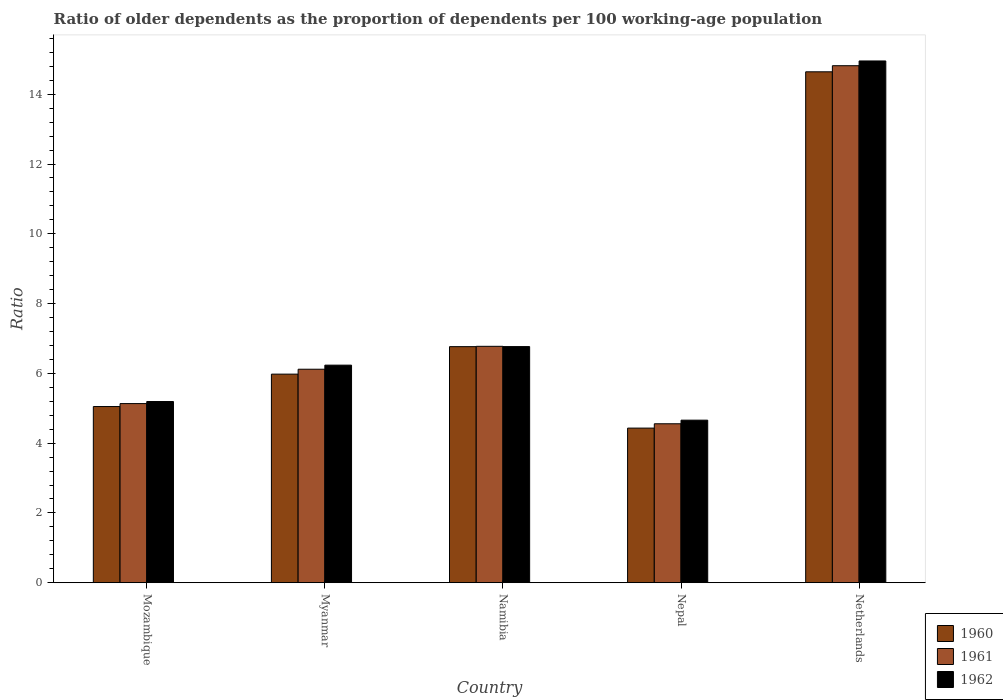How many different coloured bars are there?
Keep it short and to the point. 3. How many groups of bars are there?
Keep it short and to the point. 5. Are the number of bars on each tick of the X-axis equal?
Your response must be concise. Yes. How many bars are there on the 3rd tick from the left?
Provide a succinct answer. 3. How many bars are there on the 2nd tick from the right?
Your response must be concise. 3. What is the label of the 3rd group of bars from the left?
Offer a very short reply. Namibia. In how many cases, is the number of bars for a given country not equal to the number of legend labels?
Provide a short and direct response. 0. What is the age dependency ratio(old) in 1962 in Nepal?
Keep it short and to the point. 4.66. Across all countries, what is the maximum age dependency ratio(old) in 1961?
Your answer should be compact. 14.82. Across all countries, what is the minimum age dependency ratio(old) in 1961?
Your answer should be very brief. 4.56. In which country was the age dependency ratio(old) in 1960 maximum?
Offer a very short reply. Netherlands. In which country was the age dependency ratio(old) in 1960 minimum?
Offer a very short reply. Nepal. What is the total age dependency ratio(old) in 1962 in the graph?
Provide a succinct answer. 37.81. What is the difference between the age dependency ratio(old) in 1960 in Nepal and that in Netherlands?
Your answer should be very brief. -10.21. What is the difference between the age dependency ratio(old) in 1962 in Namibia and the age dependency ratio(old) in 1960 in Nepal?
Your answer should be very brief. 2.34. What is the average age dependency ratio(old) in 1962 per country?
Give a very brief answer. 7.56. What is the difference between the age dependency ratio(old) of/in 1960 and age dependency ratio(old) of/in 1962 in Nepal?
Give a very brief answer. -0.23. What is the ratio of the age dependency ratio(old) in 1962 in Mozambique to that in Nepal?
Your answer should be very brief. 1.11. Is the age dependency ratio(old) in 1960 in Namibia less than that in Nepal?
Ensure brevity in your answer.  No. What is the difference between the highest and the second highest age dependency ratio(old) in 1962?
Ensure brevity in your answer.  -8.72. What is the difference between the highest and the lowest age dependency ratio(old) in 1960?
Offer a very short reply. 10.21. In how many countries, is the age dependency ratio(old) in 1962 greater than the average age dependency ratio(old) in 1962 taken over all countries?
Your response must be concise. 1. Is the sum of the age dependency ratio(old) in 1960 in Mozambique and Myanmar greater than the maximum age dependency ratio(old) in 1961 across all countries?
Provide a short and direct response. No. What does the 3rd bar from the left in Netherlands represents?
Your answer should be compact. 1962. What does the 1st bar from the right in Namibia represents?
Give a very brief answer. 1962. How many countries are there in the graph?
Your answer should be very brief. 5. What is the difference between two consecutive major ticks on the Y-axis?
Your answer should be compact. 2. Are the values on the major ticks of Y-axis written in scientific E-notation?
Ensure brevity in your answer.  No. Does the graph contain any zero values?
Offer a terse response. No. Where does the legend appear in the graph?
Make the answer very short. Bottom right. What is the title of the graph?
Make the answer very short. Ratio of older dependents as the proportion of dependents per 100 working-age population. What is the label or title of the X-axis?
Your answer should be very brief. Country. What is the label or title of the Y-axis?
Provide a short and direct response. Ratio. What is the Ratio of 1960 in Mozambique?
Keep it short and to the point. 5.05. What is the Ratio of 1961 in Mozambique?
Offer a very short reply. 5.13. What is the Ratio in 1962 in Mozambique?
Your answer should be compact. 5.19. What is the Ratio in 1960 in Myanmar?
Your answer should be compact. 5.98. What is the Ratio in 1961 in Myanmar?
Offer a terse response. 6.12. What is the Ratio of 1962 in Myanmar?
Provide a short and direct response. 6.24. What is the Ratio in 1960 in Namibia?
Your answer should be compact. 6.77. What is the Ratio in 1961 in Namibia?
Give a very brief answer. 6.77. What is the Ratio of 1962 in Namibia?
Give a very brief answer. 6.77. What is the Ratio in 1960 in Nepal?
Make the answer very short. 4.43. What is the Ratio in 1961 in Nepal?
Provide a succinct answer. 4.56. What is the Ratio of 1962 in Nepal?
Offer a terse response. 4.66. What is the Ratio in 1960 in Netherlands?
Provide a short and direct response. 14.64. What is the Ratio of 1961 in Netherlands?
Provide a succinct answer. 14.82. What is the Ratio in 1962 in Netherlands?
Ensure brevity in your answer.  14.95. Across all countries, what is the maximum Ratio in 1960?
Your answer should be very brief. 14.64. Across all countries, what is the maximum Ratio in 1961?
Offer a very short reply. 14.82. Across all countries, what is the maximum Ratio in 1962?
Your response must be concise. 14.95. Across all countries, what is the minimum Ratio in 1960?
Offer a terse response. 4.43. Across all countries, what is the minimum Ratio in 1961?
Your answer should be very brief. 4.56. Across all countries, what is the minimum Ratio in 1962?
Provide a short and direct response. 4.66. What is the total Ratio in 1960 in the graph?
Keep it short and to the point. 36.87. What is the total Ratio in 1961 in the graph?
Ensure brevity in your answer.  37.4. What is the total Ratio of 1962 in the graph?
Make the answer very short. 37.81. What is the difference between the Ratio of 1960 in Mozambique and that in Myanmar?
Make the answer very short. -0.93. What is the difference between the Ratio of 1961 in Mozambique and that in Myanmar?
Your answer should be very brief. -0.98. What is the difference between the Ratio of 1962 in Mozambique and that in Myanmar?
Provide a short and direct response. -1.04. What is the difference between the Ratio of 1960 in Mozambique and that in Namibia?
Offer a very short reply. -1.72. What is the difference between the Ratio of 1961 in Mozambique and that in Namibia?
Make the answer very short. -1.64. What is the difference between the Ratio in 1962 in Mozambique and that in Namibia?
Provide a succinct answer. -1.57. What is the difference between the Ratio in 1960 in Mozambique and that in Nepal?
Your answer should be very brief. 0.62. What is the difference between the Ratio in 1961 in Mozambique and that in Nepal?
Offer a terse response. 0.58. What is the difference between the Ratio in 1962 in Mozambique and that in Nepal?
Keep it short and to the point. 0.53. What is the difference between the Ratio in 1960 in Mozambique and that in Netherlands?
Make the answer very short. -9.59. What is the difference between the Ratio in 1961 in Mozambique and that in Netherlands?
Your response must be concise. -9.68. What is the difference between the Ratio of 1962 in Mozambique and that in Netherlands?
Provide a short and direct response. -9.76. What is the difference between the Ratio of 1960 in Myanmar and that in Namibia?
Your answer should be compact. -0.79. What is the difference between the Ratio in 1961 in Myanmar and that in Namibia?
Ensure brevity in your answer.  -0.66. What is the difference between the Ratio in 1962 in Myanmar and that in Namibia?
Provide a succinct answer. -0.53. What is the difference between the Ratio in 1960 in Myanmar and that in Nepal?
Offer a very short reply. 1.55. What is the difference between the Ratio in 1961 in Myanmar and that in Nepal?
Offer a terse response. 1.56. What is the difference between the Ratio in 1962 in Myanmar and that in Nepal?
Provide a succinct answer. 1.58. What is the difference between the Ratio of 1960 in Myanmar and that in Netherlands?
Provide a short and direct response. -8.66. What is the difference between the Ratio in 1961 in Myanmar and that in Netherlands?
Give a very brief answer. -8.7. What is the difference between the Ratio of 1962 in Myanmar and that in Netherlands?
Offer a very short reply. -8.72. What is the difference between the Ratio in 1960 in Namibia and that in Nepal?
Give a very brief answer. 2.33. What is the difference between the Ratio of 1961 in Namibia and that in Nepal?
Your answer should be compact. 2.22. What is the difference between the Ratio in 1962 in Namibia and that in Nepal?
Your answer should be very brief. 2.11. What is the difference between the Ratio of 1960 in Namibia and that in Netherlands?
Provide a succinct answer. -7.88. What is the difference between the Ratio in 1961 in Namibia and that in Netherlands?
Make the answer very short. -8.04. What is the difference between the Ratio in 1962 in Namibia and that in Netherlands?
Provide a succinct answer. -8.19. What is the difference between the Ratio in 1960 in Nepal and that in Netherlands?
Ensure brevity in your answer.  -10.21. What is the difference between the Ratio in 1961 in Nepal and that in Netherlands?
Make the answer very short. -10.26. What is the difference between the Ratio of 1962 in Nepal and that in Netherlands?
Offer a very short reply. -10.29. What is the difference between the Ratio of 1960 in Mozambique and the Ratio of 1961 in Myanmar?
Your answer should be very brief. -1.07. What is the difference between the Ratio of 1960 in Mozambique and the Ratio of 1962 in Myanmar?
Your response must be concise. -1.19. What is the difference between the Ratio in 1961 in Mozambique and the Ratio in 1962 in Myanmar?
Provide a short and direct response. -1.1. What is the difference between the Ratio in 1960 in Mozambique and the Ratio in 1961 in Namibia?
Your answer should be compact. -1.73. What is the difference between the Ratio in 1960 in Mozambique and the Ratio in 1962 in Namibia?
Your answer should be compact. -1.72. What is the difference between the Ratio of 1961 in Mozambique and the Ratio of 1962 in Namibia?
Your answer should be very brief. -1.63. What is the difference between the Ratio in 1960 in Mozambique and the Ratio in 1961 in Nepal?
Give a very brief answer. 0.49. What is the difference between the Ratio of 1960 in Mozambique and the Ratio of 1962 in Nepal?
Ensure brevity in your answer.  0.39. What is the difference between the Ratio of 1961 in Mozambique and the Ratio of 1962 in Nepal?
Keep it short and to the point. 0.48. What is the difference between the Ratio of 1960 in Mozambique and the Ratio of 1961 in Netherlands?
Your answer should be very brief. -9.77. What is the difference between the Ratio in 1960 in Mozambique and the Ratio in 1962 in Netherlands?
Ensure brevity in your answer.  -9.9. What is the difference between the Ratio of 1961 in Mozambique and the Ratio of 1962 in Netherlands?
Your response must be concise. -9.82. What is the difference between the Ratio of 1960 in Myanmar and the Ratio of 1961 in Namibia?
Provide a short and direct response. -0.8. What is the difference between the Ratio of 1960 in Myanmar and the Ratio of 1962 in Namibia?
Your answer should be compact. -0.79. What is the difference between the Ratio in 1961 in Myanmar and the Ratio in 1962 in Namibia?
Keep it short and to the point. -0.65. What is the difference between the Ratio in 1960 in Myanmar and the Ratio in 1961 in Nepal?
Give a very brief answer. 1.42. What is the difference between the Ratio in 1960 in Myanmar and the Ratio in 1962 in Nepal?
Your response must be concise. 1.32. What is the difference between the Ratio in 1961 in Myanmar and the Ratio in 1962 in Nepal?
Provide a short and direct response. 1.46. What is the difference between the Ratio of 1960 in Myanmar and the Ratio of 1961 in Netherlands?
Your answer should be very brief. -8.84. What is the difference between the Ratio of 1960 in Myanmar and the Ratio of 1962 in Netherlands?
Your answer should be very brief. -8.98. What is the difference between the Ratio of 1961 in Myanmar and the Ratio of 1962 in Netherlands?
Ensure brevity in your answer.  -8.83. What is the difference between the Ratio in 1960 in Namibia and the Ratio in 1961 in Nepal?
Provide a short and direct response. 2.21. What is the difference between the Ratio in 1960 in Namibia and the Ratio in 1962 in Nepal?
Your answer should be compact. 2.11. What is the difference between the Ratio in 1961 in Namibia and the Ratio in 1962 in Nepal?
Offer a very short reply. 2.12. What is the difference between the Ratio of 1960 in Namibia and the Ratio of 1961 in Netherlands?
Ensure brevity in your answer.  -8.05. What is the difference between the Ratio in 1960 in Namibia and the Ratio in 1962 in Netherlands?
Make the answer very short. -8.19. What is the difference between the Ratio in 1961 in Namibia and the Ratio in 1962 in Netherlands?
Make the answer very short. -8.18. What is the difference between the Ratio in 1960 in Nepal and the Ratio in 1961 in Netherlands?
Your response must be concise. -10.39. What is the difference between the Ratio in 1960 in Nepal and the Ratio in 1962 in Netherlands?
Offer a terse response. -10.52. What is the difference between the Ratio of 1961 in Nepal and the Ratio of 1962 in Netherlands?
Offer a terse response. -10.4. What is the average Ratio in 1960 per country?
Give a very brief answer. 7.37. What is the average Ratio in 1961 per country?
Make the answer very short. 7.48. What is the average Ratio of 1962 per country?
Offer a terse response. 7.56. What is the difference between the Ratio of 1960 and Ratio of 1961 in Mozambique?
Give a very brief answer. -0.08. What is the difference between the Ratio of 1960 and Ratio of 1962 in Mozambique?
Your answer should be compact. -0.14. What is the difference between the Ratio in 1961 and Ratio in 1962 in Mozambique?
Give a very brief answer. -0.06. What is the difference between the Ratio of 1960 and Ratio of 1961 in Myanmar?
Ensure brevity in your answer.  -0.14. What is the difference between the Ratio of 1960 and Ratio of 1962 in Myanmar?
Your response must be concise. -0.26. What is the difference between the Ratio of 1961 and Ratio of 1962 in Myanmar?
Provide a succinct answer. -0.12. What is the difference between the Ratio of 1960 and Ratio of 1961 in Namibia?
Make the answer very short. -0.01. What is the difference between the Ratio in 1960 and Ratio in 1962 in Namibia?
Your answer should be compact. -0. What is the difference between the Ratio of 1961 and Ratio of 1962 in Namibia?
Keep it short and to the point. 0.01. What is the difference between the Ratio in 1960 and Ratio in 1961 in Nepal?
Your response must be concise. -0.12. What is the difference between the Ratio in 1960 and Ratio in 1962 in Nepal?
Give a very brief answer. -0.23. What is the difference between the Ratio of 1961 and Ratio of 1962 in Nepal?
Provide a short and direct response. -0.1. What is the difference between the Ratio in 1960 and Ratio in 1961 in Netherlands?
Keep it short and to the point. -0.17. What is the difference between the Ratio of 1960 and Ratio of 1962 in Netherlands?
Your response must be concise. -0.31. What is the difference between the Ratio in 1961 and Ratio in 1962 in Netherlands?
Provide a succinct answer. -0.14. What is the ratio of the Ratio of 1960 in Mozambique to that in Myanmar?
Your answer should be compact. 0.84. What is the ratio of the Ratio in 1961 in Mozambique to that in Myanmar?
Ensure brevity in your answer.  0.84. What is the ratio of the Ratio of 1962 in Mozambique to that in Myanmar?
Make the answer very short. 0.83. What is the ratio of the Ratio of 1960 in Mozambique to that in Namibia?
Your answer should be compact. 0.75. What is the ratio of the Ratio in 1961 in Mozambique to that in Namibia?
Offer a terse response. 0.76. What is the ratio of the Ratio in 1962 in Mozambique to that in Namibia?
Provide a short and direct response. 0.77. What is the ratio of the Ratio of 1960 in Mozambique to that in Nepal?
Offer a terse response. 1.14. What is the ratio of the Ratio in 1961 in Mozambique to that in Nepal?
Your answer should be compact. 1.13. What is the ratio of the Ratio in 1962 in Mozambique to that in Nepal?
Ensure brevity in your answer.  1.11. What is the ratio of the Ratio of 1960 in Mozambique to that in Netherlands?
Provide a succinct answer. 0.34. What is the ratio of the Ratio of 1961 in Mozambique to that in Netherlands?
Give a very brief answer. 0.35. What is the ratio of the Ratio of 1962 in Mozambique to that in Netherlands?
Your response must be concise. 0.35. What is the ratio of the Ratio in 1960 in Myanmar to that in Namibia?
Keep it short and to the point. 0.88. What is the ratio of the Ratio in 1961 in Myanmar to that in Namibia?
Provide a succinct answer. 0.9. What is the ratio of the Ratio of 1962 in Myanmar to that in Namibia?
Keep it short and to the point. 0.92. What is the ratio of the Ratio in 1960 in Myanmar to that in Nepal?
Give a very brief answer. 1.35. What is the ratio of the Ratio of 1961 in Myanmar to that in Nepal?
Offer a terse response. 1.34. What is the ratio of the Ratio in 1962 in Myanmar to that in Nepal?
Offer a terse response. 1.34. What is the ratio of the Ratio in 1960 in Myanmar to that in Netherlands?
Ensure brevity in your answer.  0.41. What is the ratio of the Ratio of 1961 in Myanmar to that in Netherlands?
Your response must be concise. 0.41. What is the ratio of the Ratio in 1962 in Myanmar to that in Netherlands?
Offer a terse response. 0.42. What is the ratio of the Ratio of 1960 in Namibia to that in Nepal?
Provide a short and direct response. 1.53. What is the ratio of the Ratio in 1961 in Namibia to that in Nepal?
Your answer should be very brief. 1.49. What is the ratio of the Ratio of 1962 in Namibia to that in Nepal?
Your response must be concise. 1.45. What is the ratio of the Ratio in 1960 in Namibia to that in Netherlands?
Your response must be concise. 0.46. What is the ratio of the Ratio in 1961 in Namibia to that in Netherlands?
Provide a succinct answer. 0.46. What is the ratio of the Ratio in 1962 in Namibia to that in Netherlands?
Ensure brevity in your answer.  0.45. What is the ratio of the Ratio of 1960 in Nepal to that in Netherlands?
Offer a terse response. 0.3. What is the ratio of the Ratio of 1961 in Nepal to that in Netherlands?
Provide a succinct answer. 0.31. What is the ratio of the Ratio of 1962 in Nepal to that in Netherlands?
Make the answer very short. 0.31. What is the difference between the highest and the second highest Ratio of 1960?
Offer a very short reply. 7.88. What is the difference between the highest and the second highest Ratio of 1961?
Your answer should be very brief. 8.04. What is the difference between the highest and the second highest Ratio of 1962?
Provide a short and direct response. 8.19. What is the difference between the highest and the lowest Ratio in 1960?
Your answer should be compact. 10.21. What is the difference between the highest and the lowest Ratio of 1961?
Offer a terse response. 10.26. What is the difference between the highest and the lowest Ratio in 1962?
Your answer should be compact. 10.29. 